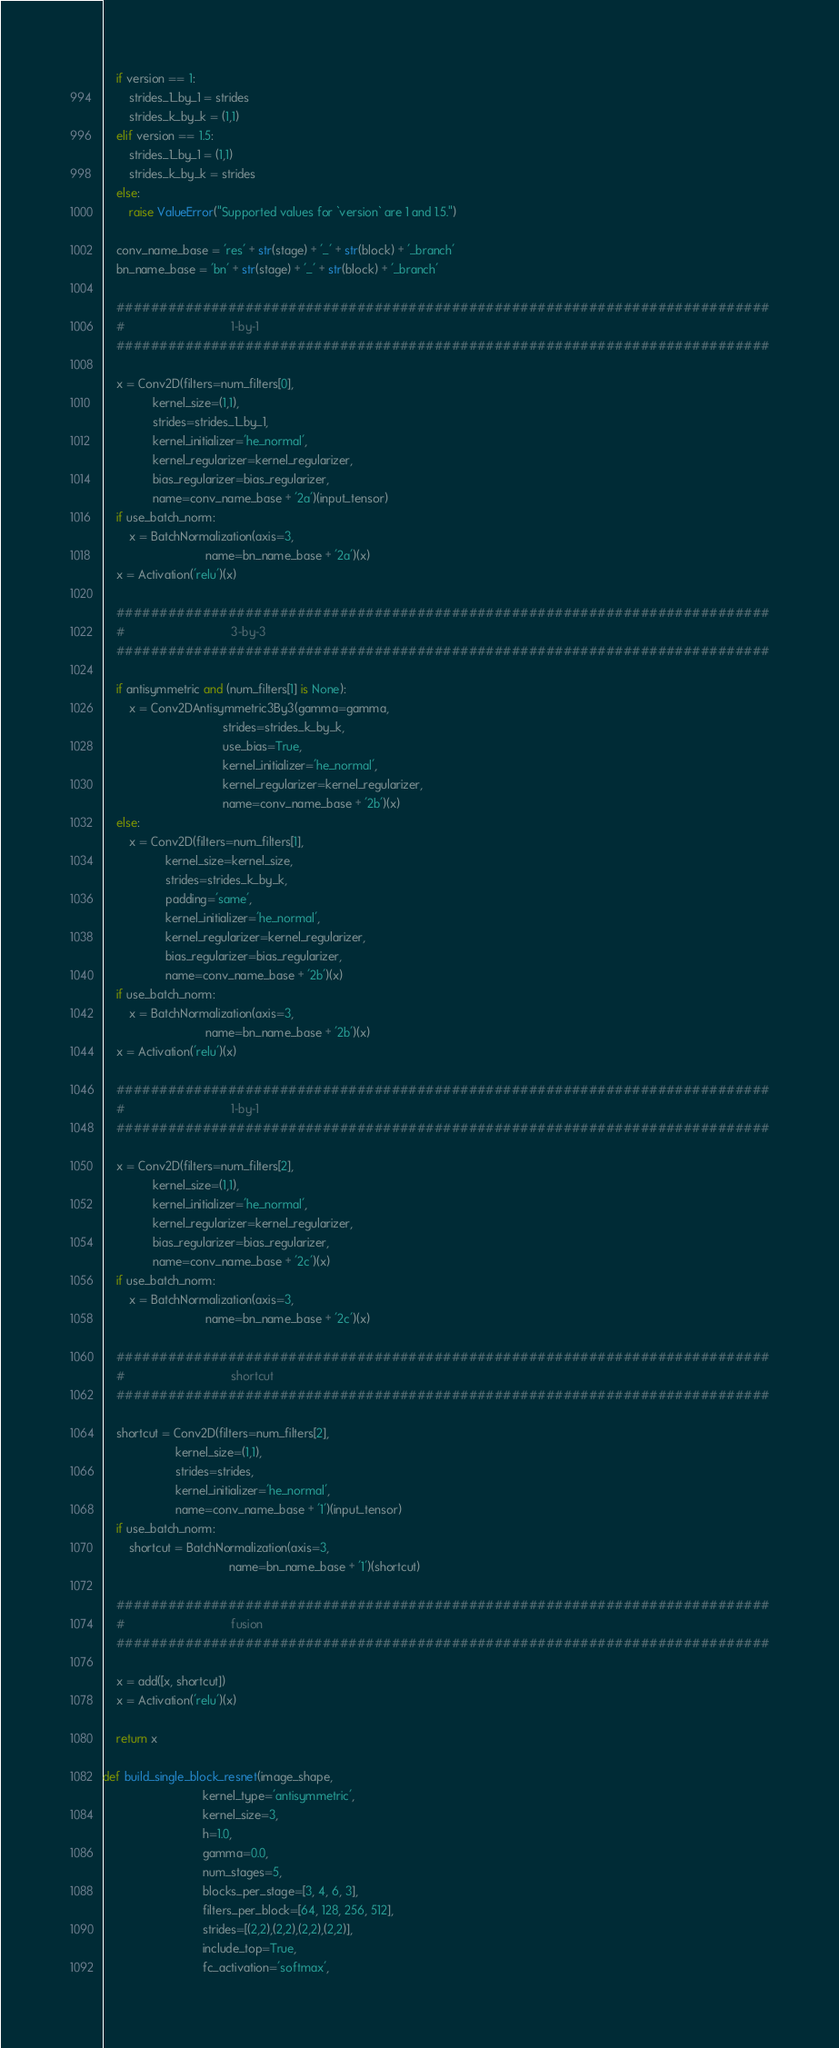<code> <loc_0><loc_0><loc_500><loc_500><_Python_>    if version == 1:
        strides_1_by_1 = strides
        strides_k_by_k = (1,1)
    elif version == 1.5:
        strides_1_by_1 = (1,1)
        strides_k_by_k = strides
    else:
        raise ValueError("Supported values for `version` are 1 and 1.5.")

    conv_name_base = 'res' + str(stage) + '_' + str(block) + '_branch'
    bn_name_base = 'bn' + str(stage) + '_' + str(block) + '_branch'

    ############################################################################
    #                                1-by-1
    ############################################################################

    x = Conv2D(filters=num_filters[0],
               kernel_size=(1,1),
               strides=strides_1_by_1,
               kernel_initializer='he_normal',
               kernel_regularizer=kernel_regularizer,
               bias_regularizer=bias_regularizer,
               name=conv_name_base + '2a')(input_tensor)
    if use_batch_norm:
        x = BatchNormalization(axis=3,
                               name=bn_name_base + '2a')(x)
    x = Activation('relu')(x)

    ############################################################################
    #                                3-by-3
    ############################################################################

    if antisymmetric and (num_filters[1] is None):
        x = Conv2DAntisymmetric3By3(gamma=gamma,
                                    strides=strides_k_by_k,
                                    use_bias=True,
                                    kernel_initializer='he_normal',
                                    kernel_regularizer=kernel_regularizer,
                                    name=conv_name_base + '2b')(x)
    else:
        x = Conv2D(filters=num_filters[1],
                   kernel_size=kernel_size,
                   strides=strides_k_by_k,
                   padding='same',
                   kernel_initializer='he_normal',
                   kernel_regularizer=kernel_regularizer,
                   bias_regularizer=bias_regularizer,
                   name=conv_name_base + '2b')(x)
    if use_batch_norm:
        x = BatchNormalization(axis=3,
                               name=bn_name_base + '2b')(x)
    x = Activation('relu')(x)

    ############################################################################
    #                                1-by-1
    ############################################################################

    x = Conv2D(filters=num_filters[2],
               kernel_size=(1,1),
               kernel_initializer='he_normal',
               kernel_regularizer=kernel_regularizer,
               bias_regularizer=bias_regularizer,
               name=conv_name_base + '2c')(x)
    if use_batch_norm:
        x = BatchNormalization(axis=3,
                               name=bn_name_base + '2c')(x)

    ############################################################################
    #                                shortcut
    ############################################################################

    shortcut = Conv2D(filters=num_filters[2],
                      kernel_size=(1,1),
                      strides=strides,
                      kernel_initializer='he_normal',
                      name=conv_name_base + '1')(input_tensor)
    if use_batch_norm:
        shortcut = BatchNormalization(axis=3,
                                      name=bn_name_base + '1')(shortcut)

    ############################################################################
    #                                fusion
    ############################################################################

    x = add([x, shortcut])
    x = Activation('relu')(x)

    return x

def build_single_block_resnet(image_shape,
                              kernel_type='antisymmetric',
                              kernel_size=3,
                              h=1.0,
                              gamma=0.0,
                              num_stages=5,
                              blocks_per_stage=[3, 4, 6, 3],
                              filters_per_block=[64, 128, 256, 512],
                              strides=[(2,2),(2,2),(2,2),(2,2)],
                              include_top=True,
                              fc_activation='softmax',</code> 